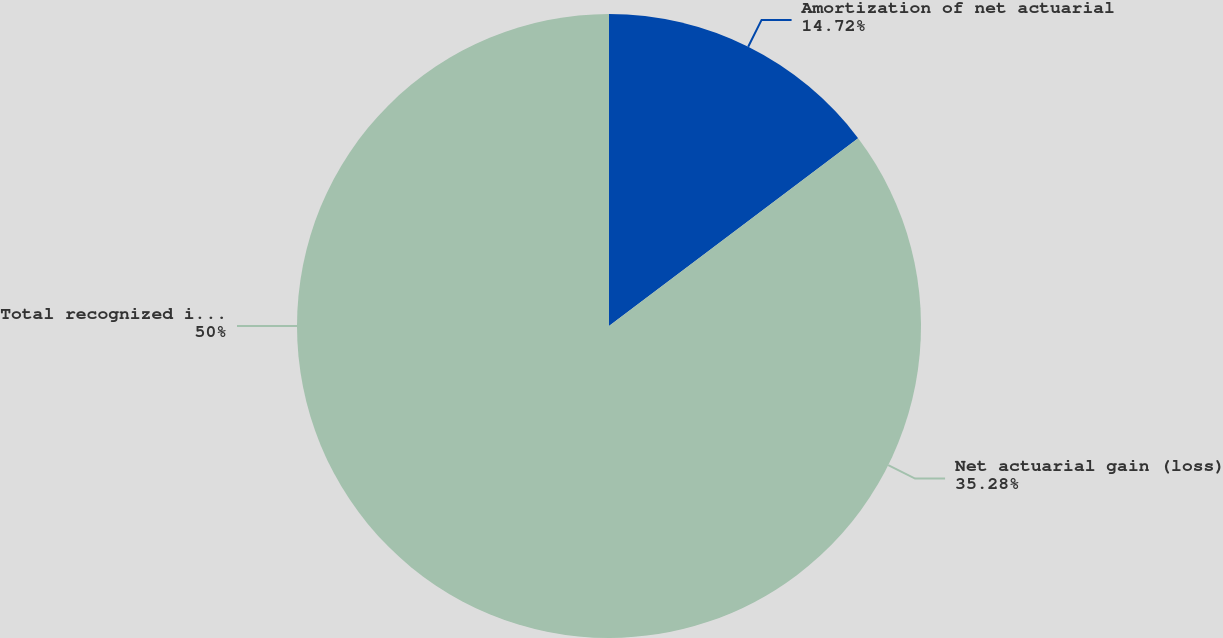Convert chart to OTSL. <chart><loc_0><loc_0><loc_500><loc_500><pie_chart><fcel>Amortization of net actuarial<fcel>Net actuarial gain (loss)<fcel>Total recognized in OCI -<nl><fcel>14.72%<fcel>35.28%<fcel>50.0%<nl></chart> 